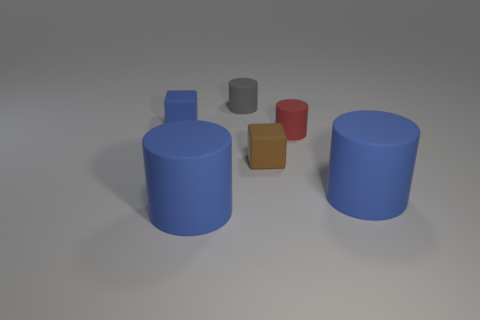What number of other gray things have the same shape as the gray object?
Give a very brief answer. 0. There is a blue matte cylinder that is to the left of the blue thing on the right side of the gray rubber cylinder; how big is it?
Your answer should be very brief. Large. How many yellow objects are large matte objects or matte cylinders?
Offer a very short reply. 0. Are there fewer rubber objects in front of the brown block than blue objects to the right of the tiny gray matte object?
Your response must be concise. No. There is a brown block; does it have the same size as the block left of the brown cube?
Provide a succinct answer. Yes. What number of red rubber objects have the same size as the brown object?
Your response must be concise. 1. What number of tiny objects are either brown objects or blue balls?
Provide a short and direct response. 1. Are any tiny red matte cylinders visible?
Give a very brief answer. Yes. Is the number of blue cubes that are behind the blue rubber cube greater than the number of red things behind the gray rubber cylinder?
Make the answer very short. No. What color is the tiny thing on the left side of the small rubber cylinder on the left side of the tiny brown matte block?
Ensure brevity in your answer.  Blue. 